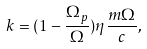<formula> <loc_0><loc_0><loc_500><loc_500>k = ( 1 - \frac { \Omega _ { p } } { \Omega } ) \eta \frac { m \Omega } { c } ,</formula> 